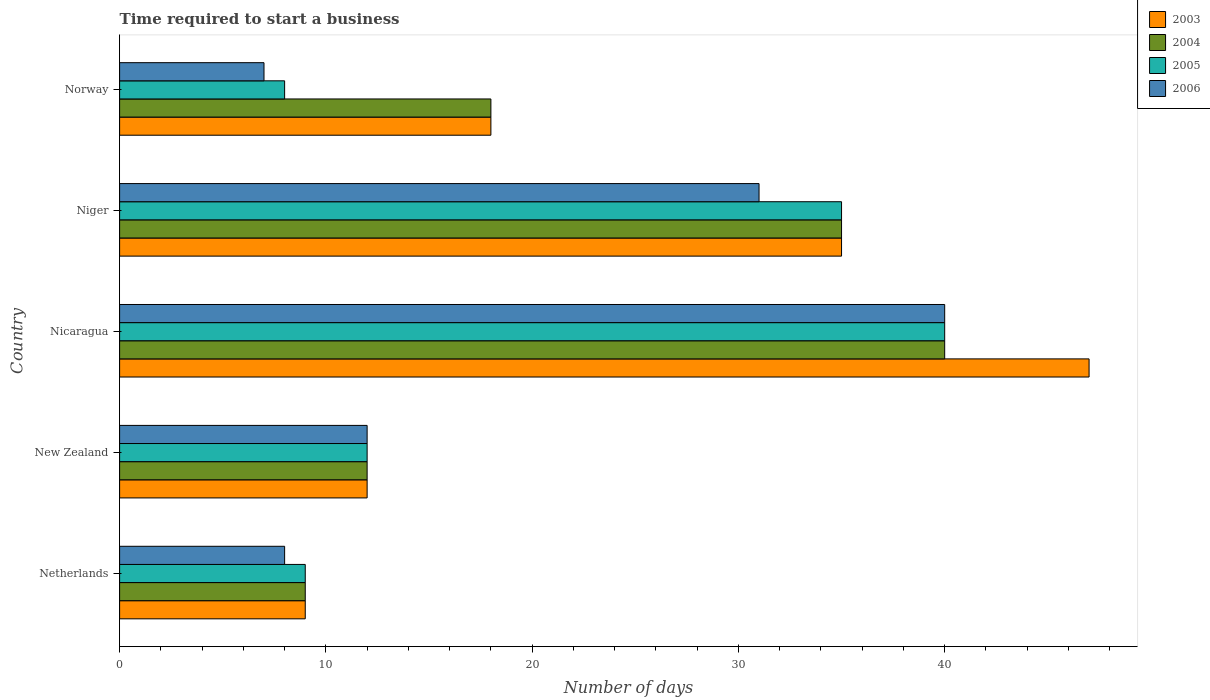How many groups of bars are there?
Your answer should be compact. 5. Are the number of bars per tick equal to the number of legend labels?
Provide a succinct answer. Yes. Are the number of bars on each tick of the Y-axis equal?
Provide a short and direct response. Yes. What is the label of the 3rd group of bars from the top?
Make the answer very short. Nicaragua. Across all countries, what is the maximum number of days required to start a business in 2006?
Offer a very short reply. 40. Across all countries, what is the minimum number of days required to start a business in 2004?
Give a very brief answer. 9. In which country was the number of days required to start a business in 2004 maximum?
Provide a succinct answer. Nicaragua. What is the total number of days required to start a business in 2004 in the graph?
Your response must be concise. 114. What is the average number of days required to start a business in 2005 per country?
Provide a succinct answer. 20.8. What is the difference between the number of days required to start a business in 2005 and number of days required to start a business in 2006 in Niger?
Keep it short and to the point. 4. What is the ratio of the number of days required to start a business in 2003 in Netherlands to that in New Zealand?
Your answer should be compact. 0.75. Is the number of days required to start a business in 2005 in Nicaragua less than that in Norway?
Provide a succinct answer. No. Is the difference between the number of days required to start a business in 2005 in Netherlands and Nicaragua greater than the difference between the number of days required to start a business in 2006 in Netherlands and Nicaragua?
Your answer should be compact. Yes. What is the difference between the highest and the second highest number of days required to start a business in 2006?
Ensure brevity in your answer.  9. In how many countries, is the number of days required to start a business in 2006 greater than the average number of days required to start a business in 2006 taken over all countries?
Your answer should be compact. 2. Is the sum of the number of days required to start a business in 2006 in New Zealand and Norway greater than the maximum number of days required to start a business in 2004 across all countries?
Offer a terse response. No. What does the 2nd bar from the bottom in New Zealand represents?
Make the answer very short. 2004. Is it the case that in every country, the sum of the number of days required to start a business in 2005 and number of days required to start a business in 2004 is greater than the number of days required to start a business in 2006?
Offer a terse response. Yes. What is the difference between two consecutive major ticks on the X-axis?
Your answer should be compact. 10. Does the graph contain grids?
Offer a very short reply. No. Where does the legend appear in the graph?
Your answer should be very brief. Top right. How are the legend labels stacked?
Ensure brevity in your answer.  Vertical. What is the title of the graph?
Your answer should be very brief. Time required to start a business. Does "2005" appear as one of the legend labels in the graph?
Provide a succinct answer. Yes. What is the label or title of the X-axis?
Offer a terse response. Number of days. What is the Number of days of 2005 in New Zealand?
Offer a very short reply. 12. What is the Number of days of 2006 in New Zealand?
Give a very brief answer. 12. What is the Number of days in 2003 in Nicaragua?
Provide a succinct answer. 47. What is the Number of days in 2005 in Nicaragua?
Offer a very short reply. 40. What is the Number of days in 2003 in Niger?
Ensure brevity in your answer.  35. What is the Number of days in 2004 in Niger?
Your answer should be very brief. 35. What is the Number of days of 2006 in Niger?
Your answer should be compact. 31. What is the Number of days of 2003 in Norway?
Provide a short and direct response. 18. What is the Number of days of 2004 in Norway?
Give a very brief answer. 18. What is the Number of days of 2005 in Norway?
Your response must be concise. 8. Across all countries, what is the maximum Number of days of 2006?
Ensure brevity in your answer.  40. Across all countries, what is the minimum Number of days of 2006?
Your answer should be compact. 7. What is the total Number of days of 2003 in the graph?
Your answer should be very brief. 121. What is the total Number of days of 2004 in the graph?
Ensure brevity in your answer.  114. What is the total Number of days in 2005 in the graph?
Your answer should be very brief. 104. What is the difference between the Number of days in 2003 in Netherlands and that in New Zealand?
Provide a short and direct response. -3. What is the difference between the Number of days in 2006 in Netherlands and that in New Zealand?
Give a very brief answer. -4. What is the difference between the Number of days in 2003 in Netherlands and that in Nicaragua?
Your answer should be very brief. -38. What is the difference between the Number of days in 2004 in Netherlands and that in Nicaragua?
Offer a terse response. -31. What is the difference between the Number of days in 2005 in Netherlands and that in Nicaragua?
Your response must be concise. -31. What is the difference between the Number of days of 2006 in Netherlands and that in Nicaragua?
Give a very brief answer. -32. What is the difference between the Number of days of 2003 in Netherlands and that in Niger?
Provide a succinct answer. -26. What is the difference between the Number of days in 2004 in Netherlands and that in Niger?
Give a very brief answer. -26. What is the difference between the Number of days of 2003 in Netherlands and that in Norway?
Keep it short and to the point. -9. What is the difference between the Number of days of 2004 in Netherlands and that in Norway?
Make the answer very short. -9. What is the difference between the Number of days in 2003 in New Zealand and that in Nicaragua?
Offer a terse response. -35. What is the difference between the Number of days in 2004 in New Zealand and that in Nicaragua?
Your response must be concise. -28. What is the difference between the Number of days of 2005 in New Zealand and that in Nicaragua?
Ensure brevity in your answer.  -28. What is the difference between the Number of days in 2003 in New Zealand and that in Niger?
Your answer should be compact. -23. What is the difference between the Number of days of 2004 in New Zealand and that in Niger?
Keep it short and to the point. -23. What is the difference between the Number of days of 2006 in New Zealand and that in Niger?
Your answer should be compact. -19. What is the difference between the Number of days in 2003 in New Zealand and that in Norway?
Provide a short and direct response. -6. What is the difference between the Number of days in 2004 in New Zealand and that in Norway?
Provide a succinct answer. -6. What is the difference between the Number of days of 2006 in New Zealand and that in Norway?
Your response must be concise. 5. What is the difference between the Number of days of 2003 in Nicaragua and that in Niger?
Give a very brief answer. 12. What is the difference between the Number of days of 2005 in Nicaragua and that in Norway?
Give a very brief answer. 32. What is the difference between the Number of days of 2006 in Nicaragua and that in Norway?
Give a very brief answer. 33. What is the difference between the Number of days of 2005 in Niger and that in Norway?
Provide a succinct answer. 27. What is the difference between the Number of days of 2003 in Netherlands and the Number of days of 2005 in New Zealand?
Offer a terse response. -3. What is the difference between the Number of days of 2003 in Netherlands and the Number of days of 2006 in New Zealand?
Make the answer very short. -3. What is the difference between the Number of days of 2004 in Netherlands and the Number of days of 2005 in New Zealand?
Ensure brevity in your answer.  -3. What is the difference between the Number of days in 2005 in Netherlands and the Number of days in 2006 in New Zealand?
Provide a short and direct response. -3. What is the difference between the Number of days in 2003 in Netherlands and the Number of days in 2004 in Nicaragua?
Your answer should be compact. -31. What is the difference between the Number of days in 2003 in Netherlands and the Number of days in 2005 in Nicaragua?
Ensure brevity in your answer.  -31. What is the difference between the Number of days in 2003 in Netherlands and the Number of days in 2006 in Nicaragua?
Provide a succinct answer. -31. What is the difference between the Number of days in 2004 in Netherlands and the Number of days in 2005 in Nicaragua?
Offer a very short reply. -31. What is the difference between the Number of days of 2004 in Netherlands and the Number of days of 2006 in Nicaragua?
Provide a short and direct response. -31. What is the difference between the Number of days in 2005 in Netherlands and the Number of days in 2006 in Nicaragua?
Keep it short and to the point. -31. What is the difference between the Number of days in 2003 in Netherlands and the Number of days in 2005 in Niger?
Provide a succinct answer. -26. What is the difference between the Number of days of 2004 in Netherlands and the Number of days of 2005 in Niger?
Give a very brief answer. -26. What is the difference between the Number of days of 2004 in Netherlands and the Number of days of 2006 in Niger?
Ensure brevity in your answer.  -22. What is the difference between the Number of days of 2004 in Netherlands and the Number of days of 2006 in Norway?
Ensure brevity in your answer.  2. What is the difference between the Number of days in 2005 in Netherlands and the Number of days in 2006 in Norway?
Your answer should be compact. 2. What is the difference between the Number of days in 2003 in New Zealand and the Number of days in 2004 in Nicaragua?
Offer a terse response. -28. What is the difference between the Number of days in 2003 in New Zealand and the Number of days in 2005 in Nicaragua?
Your response must be concise. -28. What is the difference between the Number of days of 2004 in New Zealand and the Number of days of 2006 in Nicaragua?
Offer a very short reply. -28. What is the difference between the Number of days in 2005 in New Zealand and the Number of days in 2006 in Nicaragua?
Provide a short and direct response. -28. What is the difference between the Number of days in 2003 in New Zealand and the Number of days in 2005 in Niger?
Provide a succinct answer. -23. What is the difference between the Number of days in 2005 in New Zealand and the Number of days in 2006 in Niger?
Ensure brevity in your answer.  -19. What is the difference between the Number of days in 2003 in New Zealand and the Number of days in 2004 in Norway?
Offer a terse response. -6. What is the difference between the Number of days of 2003 in New Zealand and the Number of days of 2005 in Norway?
Offer a terse response. 4. What is the difference between the Number of days of 2003 in New Zealand and the Number of days of 2006 in Norway?
Offer a very short reply. 5. What is the difference between the Number of days in 2004 in New Zealand and the Number of days in 2005 in Norway?
Provide a succinct answer. 4. What is the difference between the Number of days in 2004 in New Zealand and the Number of days in 2006 in Norway?
Ensure brevity in your answer.  5. What is the difference between the Number of days in 2003 in Nicaragua and the Number of days in 2006 in Niger?
Offer a very short reply. 16. What is the difference between the Number of days in 2004 in Nicaragua and the Number of days in 2005 in Niger?
Provide a short and direct response. 5. What is the difference between the Number of days in 2005 in Nicaragua and the Number of days in 2006 in Niger?
Ensure brevity in your answer.  9. What is the difference between the Number of days of 2003 in Nicaragua and the Number of days of 2004 in Norway?
Your answer should be very brief. 29. What is the difference between the Number of days in 2003 in Nicaragua and the Number of days in 2005 in Norway?
Offer a terse response. 39. What is the difference between the Number of days in 2003 in Nicaragua and the Number of days in 2006 in Norway?
Make the answer very short. 40. What is the difference between the Number of days of 2004 in Nicaragua and the Number of days of 2005 in Norway?
Give a very brief answer. 32. What is the difference between the Number of days in 2003 in Niger and the Number of days in 2004 in Norway?
Ensure brevity in your answer.  17. What is the difference between the Number of days of 2004 in Niger and the Number of days of 2006 in Norway?
Ensure brevity in your answer.  28. What is the average Number of days of 2003 per country?
Ensure brevity in your answer.  24.2. What is the average Number of days of 2004 per country?
Offer a very short reply. 22.8. What is the average Number of days of 2005 per country?
Your answer should be very brief. 20.8. What is the average Number of days in 2006 per country?
Provide a short and direct response. 19.6. What is the difference between the Number of days in 2003 and Number of days in 2006 in Netherlands?
Provide a succinct answer. 1. What is the difference between the Number of days of 2004 and Number of days of 2005 in Netherlands?
Make the answer very short. 0. What is the difference between the Number of days in 2005 and Number of days in 2006 in Netherlands?
Your answer should be compact. 1. What is the difference between the Number of days in 2003 and Number of days in 2004 in New Zealand?
Ensure brevity in your answer.  0. What is the difference between the Number of days of 2003 and Number of days of 2005 in New Zealand?
Provide a succinct answer. 0. What is the difference between the Number of days of 2003 and Number of days of 2006 in New Zealand?
Make the answer very short. 0. What is the difference between the Number of days of 2004 and Number of days of 2005 in New Zealand?
Keep it short and to the point. 0. What is the difference between the Number of days in 2004 and Number of days in 2006 in New Zealand?
Your answer should be compact. 0. What is the difference between the Number of days in 2003 and Number of days in 2004 in Nicaragua?
Provide a short and direct response. 7. What is the difference between the Number of days in 2005 and Number of days in 2006 in Nicaragua?
Keep it short and to the point. 0. What is the difference between the Number of days in 2003 and Number of days in 2005 in Niger?
Your answer should be compact. 0. What is the difference between the Number of days of 2005 and Number of days of 2006 in Niger?
Keep it short and to the point. 4. What is the difference between the Number of days of 2003 and Number of days of 2005 in Norway?
Your response must be concise. 10. What is the difference between the Number of days of 2003 and Number of days of 2006 in Norway?
Your response must be concise. 11. What is the difference between the Number of days in 2004 and Number of days in 2006 in Norway?
Your answer should be very brief. 11. What is the difference between the Number of days in 2005 and Number of days in 2006 in Norway?
Provide a succinct answer. 1. What is the ratio of the Number of days of 2004 in Netherlands to that in New Zealand?
Make the answer very short. 0.75. What is the ratio of the Number of days of 2005 in Netherlands to that in New Zealand?
Provide a short and direct response. 0.75. What is the ratio of the Number of days in 2006 in Netherlands to that in New Zealand?
Provide a short and direct response. 0.67. What is the ratio of the Number of days of 2003 in Netherlands to that in Nicaragua?
Make the answer very short. 0.19. What is the ratio of the Number of days in 2004 in Netherlands to that in Nicaragua?
Provide a short and direct response. 0.23. What is the ratio of the Number of days in 2005 in Netherlands to that in Nicaragua?
Offer a terse response. 0.23. What is the ratio of the Number of days in 2003 in Netherlands to that in Niger?
Offer a very short reply. 0.26. What is the ratio of the Number of days of 2004 in Netherlands to that in Niger?
Give a very brief answer. 0.26. What is the ratio of the Number of days in 2005 in Netherlands to that in Niger?
Provide a succinct answer. 0.26. What is the ratio of the Number of days in 2006 in Netherlands to that in Niger?
Make the answer very short. 0.26. What is the ratio of the Number of days in 2003 in Netherlands to that in Norway?
Provide a succinct answer. 0.5. What is the ratio of the Number of days of 2005 in Netherlands to that in Norway?
Offer a very short reply. 1.12. What is the ratio of the Number of days in 2006 in Netherlands to that in Norway?
Your answer should be compact. 1.14. What is the ratio of the Number of days in 2003 in New Zealand to that in Nicaragua?
Make the answer very short. 0.26. What is the ratio of the Number of days of 2004 in New Zealand to that in Nicaragua?
Make the answer very short. 0.3. What is the ratio of the Number of days of 2006 in New Zealand to that in Nicaragua?
Provide a short and direct response. 0.3. What is the ratio of the Number of days in 2003 in New Zealand to that in Niger?
Your answer should be very brief. 0.34. What is the ratio of the Number of days of 2004 in New Zealand to that in Niger?
Ensure brevity in your answer.  0.34. What is the ratio of the Number of days in 2005 in New Zealand to that in Niger?
Ensure brevity in your answer.  0.34. What is the ratio of the Number of days in 2006 in New Zealand to that in Niger?
Your response must be concise. 0.39. What is the ratio of the Number of days in 2006 in New Zealand to that in Norway?
Your response must be concise. 1.71. What is the ratio of the Number of days of 2003 in Nicaragua to that in Niger?
Your answer should be very brief. 1.34. What is the ratio of the Number of days in 2006 in Nicaragua to that in Niger?
Your answer should be compact. 1.29. What is the ratio of the Number of days of 2003 in Nicaragua to that in Norway?
Keep it short and to the point. 2.61. What is the ratio of the Number of days of 2004 in Nicaragua to that in Norway?
Your answer should be very brief. 2.22. What is the ratio of the Number of days in 2005 in Nicaragua to that in Norway?
Make the answer very short. 5. What is the ratio of the Number of days in 2006 in Nicaragua to that in Norway?
Offer a terse response. 5.71. What is the ratio of the Number of days in 2003 in Niger to that in Norway?
Ensure brevity in your answer.  1.94. What is the ratio of the Number of days of 2004 in Niger to that in Norway?
Keep it short and to the point. 1.94. What is the ratio of the Number of days of 2005 in Niger to that in Norway?
Your response must be concise. 4.38. What is the ratio of the Number of days of 2006 in Niger to that in Norway?
Your answer should be compact. 4.43. What is the difference between the highest and the second highest Number of days of 2004?
Give a very brief answer. 5. What is the difference between the highest and the second highest Number of days of 2005?
Ensure brevity in your answer.  5. What is the difference between the highest and the second highest Number of days in 2006?
Keep it short and to the point. 9. What is the difference between the highest and the lowest Number of days of 2003?
Your answer should be compact. 38. What is the difference between the highest and the lowest Number of days of 2004?
Ensure brevity in your answer.  31. What is the difference between the highest and the lowest Number of days in 2005?
Provide a short and direct response. 32. What is the difference between the highest and the lowest Number of days of 2006?
Provide a succinct answer. 33. 